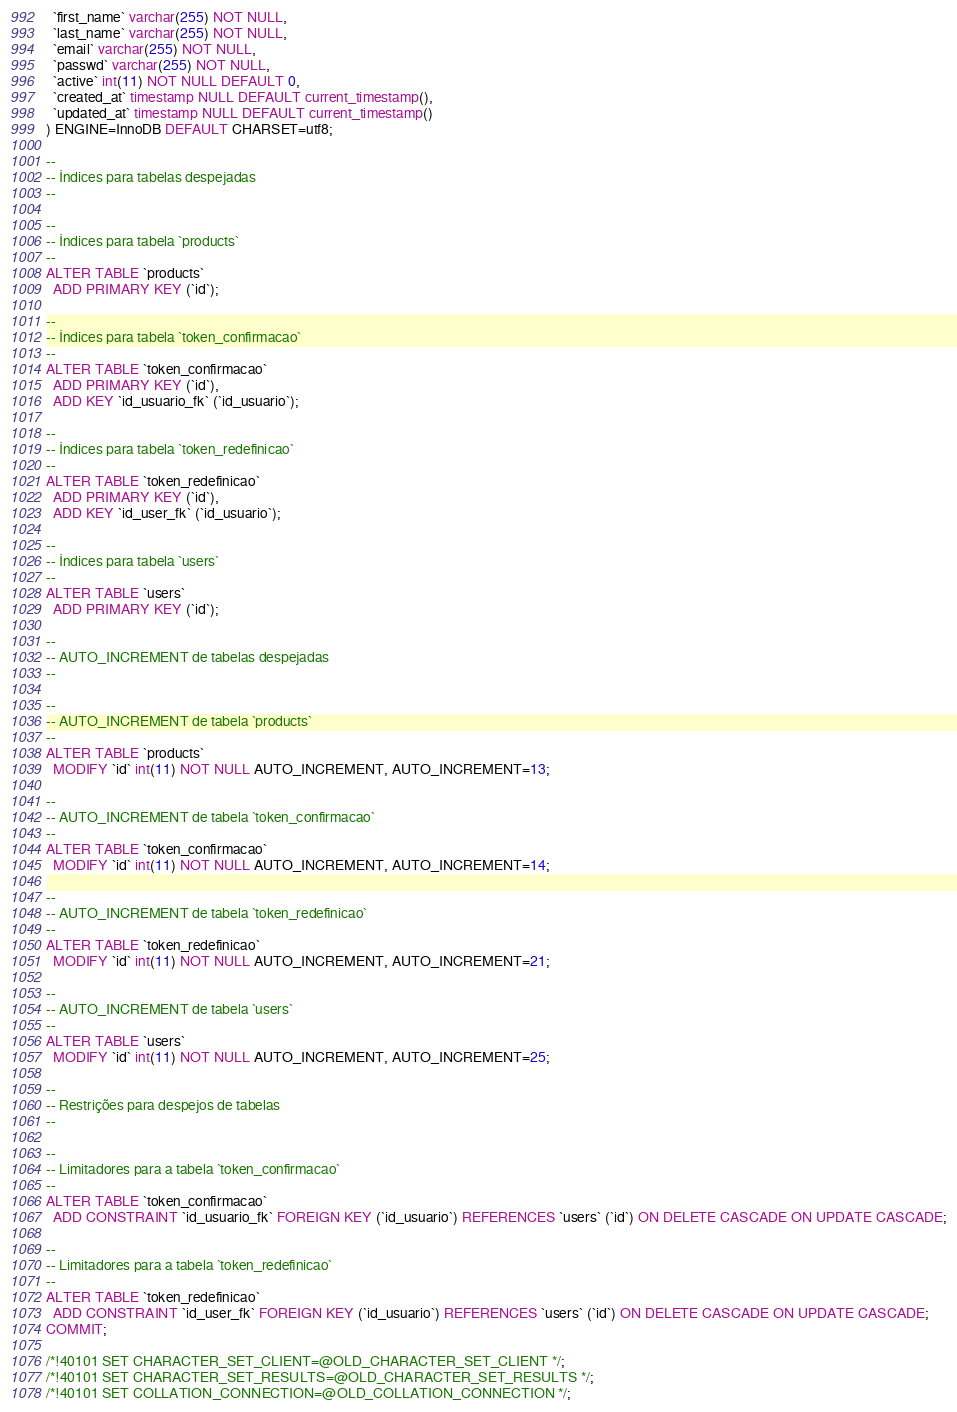<code> <loc_0><loc_0><loc_500><loc_500><_SQL_>  `first_name` varchar(255) NOT NULL,
  `last_name` varchar(255) NOT NULL,
  `email` varchar(255) NOT NULL,
  `passwd` varchar(255) NOT NULL,
  `active` int(11) NOT NULL DEFAULT 0,
  `created_at` timestamp NULL DEFAULT current_timestamp(),
  `updated_at` timestamp NULL DEFAULT current_timestamp()
) ENGINE=InnoDB DEFAULT CHARSET=utf8;

--
-- Índices para tabelas despejadas
--

--
-- Índices para tabela `products`
--
ALTER TABLE `products`
  ADD PRIMARY KEY (`id`);

--
-- Índices para tabela `token_confirmacao`
--
ALTER TABLE `token_confirmacao`
  ADD PRIMARY KEY (`id`),
  ADD KEY `id_usuario_fk` (`id_usuario`);

--
-- Índices para tabela `token_redefinicao`
--
ALTER TABLE `token_redefinicao`
  ADD PRIMARY KEY (`id`),
  ADD KEY `id_user_fk` (`id_usuario`);

--
-- Índices para tabela `users`
--
ALTER TABLE `users`
  ADD PRIMARY KEY (`id`);

--
-- AUTO_INCREMENT de tabelas despejadas
--

--
-- AUTO_INCREMENT de tabela `products`
--
ALTER TABLE `products`
  MODIFY `id` int(11) NOT NULL AUTO_INCREMENT, AUTO_INCREMENT=13;

--
-- AUTO_INCREMENT de tabela `token_confirmacao`
--
ALTER TABLE `token_confirmacao`
  MODIFY `id` int(11) NOT NULL AUTO_INCREMENT, AUTO_INCREMENT=14;

--
-- AUTO_INCREMENT de tabela `token_redefinicao`
--
ALTER TABLE `token_redefinicao`
  MODIFY `id` int(11) NOT NULL AUTO_INCREMENT, AUTO_INCREMENT=21;

--
-- AUTO_INCREMENT de tabela `users`
--
ALTER TABLE `users`
  MODIFY `id` int(11) NOT NULL AUTO_INCREMENT, AUTO_INCREMENT=25;

--
-- Restrições para despejos de tabelas
--

--
-- Limitadores para a tabela `token_confirmacao`
--
ALTER TABLE `token_confirmacao`
  ADD CONSTRAINT `id_usuario_fk` FOREIGN KEY (`id_usuario`) REFERENCES `users` (`id`) ON DELETE CASCADE ON UPDATE CASCADE;

--
-- Limitadores para a tabela `token_redefinicao`
--
ALTER TABLE `token_redefinicao`
  ADD CONSTRAINT `id_user_fk` FOREIGN KEY (`id_usuario`) REFERENCES `users` (`id`) ON DELETE CASCADE ON UPDATE CASCADE;
COMMIT;

/*!40101 SET CHARACTER_SET_CLIENT=@OLD_CHARACTER_SET_CLIENT */;
/*!40101 SET CHARACTER_SET_RESULTS=@OLD_CHARACTER_SET_RESULTS */;
/*!40101 SET COLLATION_CONNECTION=@OLD_COLLATION_CONNECTION */;
</code> 